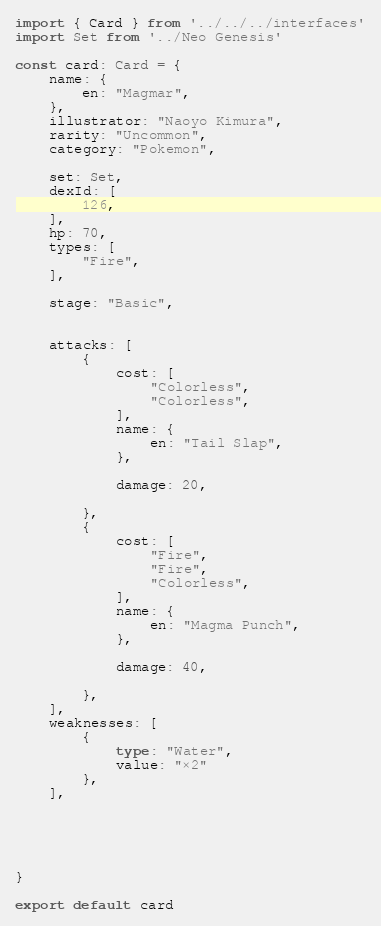Convert code to text. <code><loc_0><loc_0><loc_500><loc_500><_TypeScript_>import { Card } from '../../../interfaces'
import Set from '../Neo Genesis'

const card: Card = {
	name: {
		en: "Magmar",
	},
	illustrator: "Naoyo Kimura",
	rarity: "Uncommon",
	category: "Pokemon",

	set: Set,
	dexId: [
		126,
	],
	hp: 70,
	types: [
		"Fire",
	],

	stage: "Basic",


	attacks: [
		{
			cost: [
				"Colorless",
				"Colorless",
			],
			name: {
				en: "Tail Slap",
			},

			damage: 20,

		},
		{
			cost: [
				"Fire",
				"Fire",
				"Colorless",
			],
			name: {
				en: "Magma Punch",
			},

			damage: 40,

		},
	],
	weaknesses: [
		{
			type: "Water",
			value: "×2"
		},
	],





}

export default card
</code> 